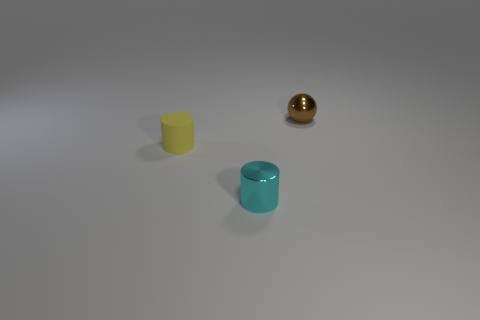What number of large things are metal objects or gray cubes?
Ensure brevity in your answer.  0. How many other objects are the same color as the ball?
Your answer should be compact. 0. Are the tiny sphere and the small object that is left of the tiny cyan metallic thing made of the same material?
Offer a very short reply. No. Are there more yellow matte cylinders behind the small brown thing than tiny brown spheres that are in front of the tiny yellow rubber object?
Keep it short and to the point. No. The thing that is to the left of the tiny metal cylinder that is in front of the yellow rubber thing is what color?
Offer a very short reply. Yellow. What number of cylinders are shiny things or small cyan metallic objects?
Give a very brief answer. 1. What number of tiny cylinders are behind the shiny cylinder and on the right side of the yellow matte cylinder?
Your answer should be very brief. 0. What is the color of the tiny object to the left of the metallic cylinder?
Make the answer very short. Yellow. There is a tiny object that is behind the yellow rubber cylinder; how many small brown shiny balls are left of it?
Provide a short and direct response. 0. What number of tiny things are to the right of the brown shiny sphere?
Offer a terse response. 0. 